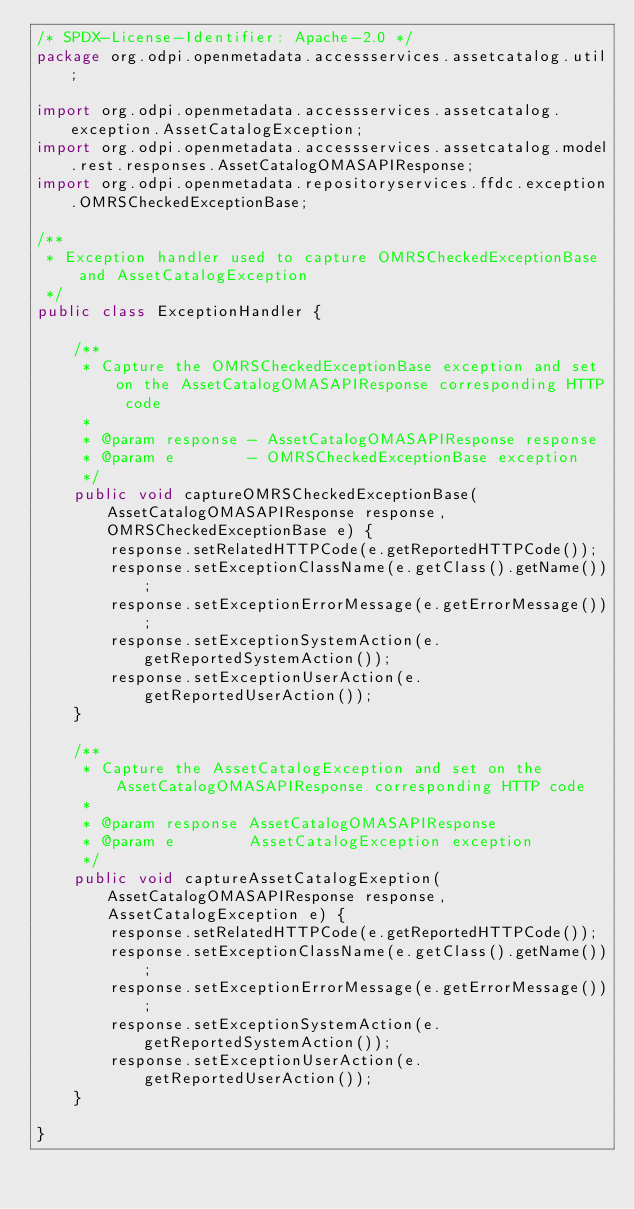<code> <loc_0><loc_0><loc_500><loc_500><_Java_>/* SPDX-License-Identifier: Apache-2.0 */
package org.odpi.openmetadata.accessservices.assetcatalog.util;

import org.odpi.openmetadata.accessservices.assetcatalog.exception.AssetCatalogException;
import org.odpi.openmetadata.accessservices.assetcatalog.model.rest.responses.AssetCatalogOMASAPIResponse;
import org.odpi.openmetadata.repositoryservices.ffdc.exception.OMRSCheckedExceptionBase;

/**
 * Exception handler used to capture OMRSCheckedExceptionBase and AssetCatalogException
 */
public class ExceptionHandler {

    /**
     * Capture the OMRSCheckedExceptionBase exception and set on the AssetCatalogOMASAPIResponse corresponding HTTP code
     *
     * @param response - AssetCatalogOMASAPIResponse response
     * @param e        - OMRSCheckedExceptionBase exception
     */
    public void captureOMRSCheckedExceptionBase(AssetCatalogOMASAPIResponse response, OMRSCheckedExceptionBase e) {
        response.setRelatedHTTPCode(e.getReportedHTTPCode());
        response.setExceptionClassName(e.getClass().getName());
        response.setExceptionErrorMessage(e.getErrorMessage());
        response.setExceptionSystemAction(e.getReportedSystemAction());
        response.setExceptionUserAction(e.getReportedUserAction());
    }

    /**
     * Capture the AssetCatalogException and set on the AssetCatalogOMASAPIResponse corresponding HTTP code
     *
     * @param response AssetCatalogOMASAPIResponse
     * @param e        AssetCatalogException exception
     */
    public void captureAssetCatalogExeption(AssetCatalogOMASAPIResponse response, AssetCatalogException e) {
        response.setRelatedHTTPCode(e.getReportedHTTPCode());
        response.setExceptionClassName(e.getClass().getName());
        response.setExceptionErrorMessage(e.getErrorMessage());
        response.setExceptionSystemAction(e.getReportedSystemAction());
        response.setExceptionUserAction(e.getReportedUserAction());
    }

}
</code> 